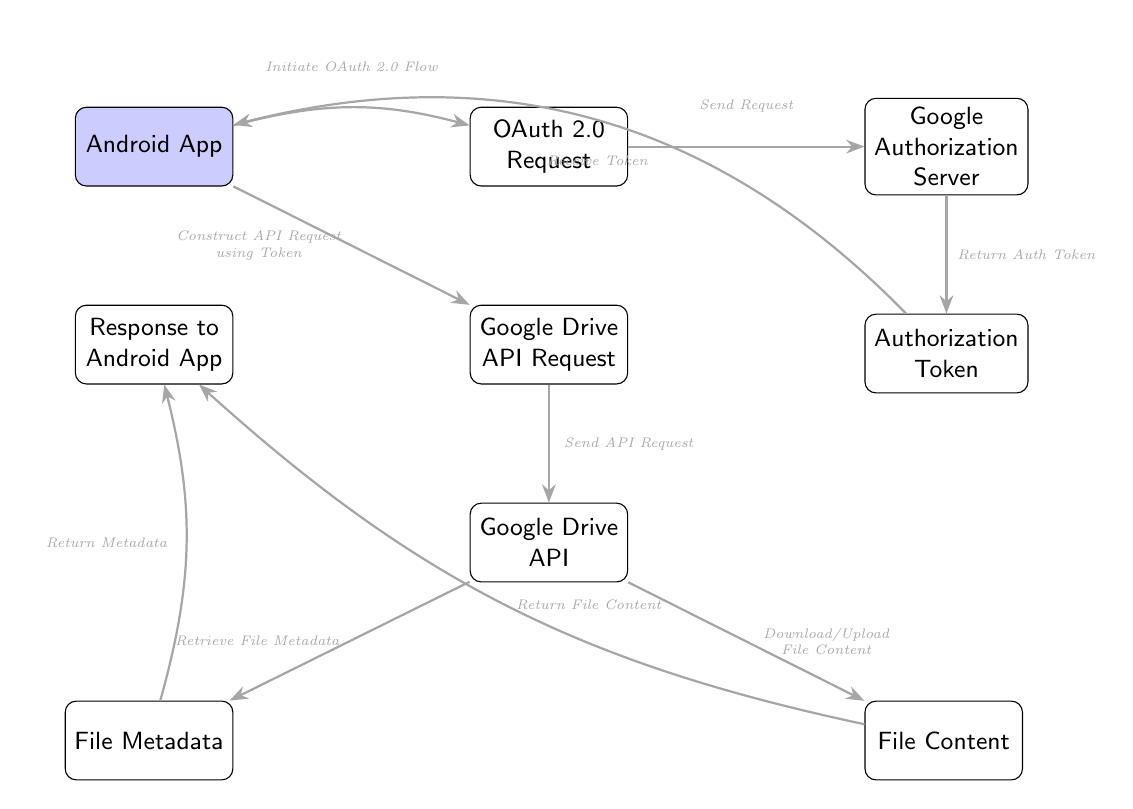What is the first node in the diagram? The first node from the left is labeled "Android App", as it is the starting point of the flow indicating where the integration process begins.
Answer: Android App How many main nodes are there in the diagram? By counting each distinct node represented, which includes the Android App, OAuth Request, Authorization Server, Authorization Token, API Request, Google Drive API, File Metadata, File Content, and Response to Android App, we find a total of 9 main nodes.
Answer: 9 What operation does the "oauth" node represent? The "oauth" node signifies the initiation of the OAuth 2.0 request process, which is essential for authentication and authorization in using the Google Drive API.
Answer: OAuth 2.0 Request Which node sends the API request? The "api_request" node sends the API request to the Google Drive API, as indicated by the arrow leading from it to the "drive_api" node.
Answer: Google Drive API Request What does the "auth_server" node return? The "auth_server" node returns an authorization token to the "token" node, which is necessary for authenticating further requests to the Google Drive API.
Answer: Authorization Token What is the final response sent to? The final response after processing the API request is sent back to the "Android App", indicating the completion of the data flow by returning either file metadata or file content.
Answer: Android App What type of data does the "drive_api" node retrieve? The "drive_api" node retrieves file metadata as well as file content, based on the API request processed through it; this shows how it interacts with user data stored on Google Drive.
Answer: File Metadata and File Content How many arrows are in the diagram? By counting all the arrows that denote the flow between nodes, we see there are 8 arrows showing the direction of the operations and responses throughout the data flow.
Answer: 8 What action follows after receiving the authorization token? After receiving the authorization token, the next action involves the Android app constructing the API request using that token, as depicted in the diagram's flow.
Answer: Construct API Request using Token 